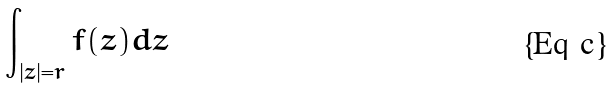Convert formula to latex. <formula><loc_0><loc_0><loc_500><loc_500>\int _ { | z | = r } f ( z ) d z</formula> 